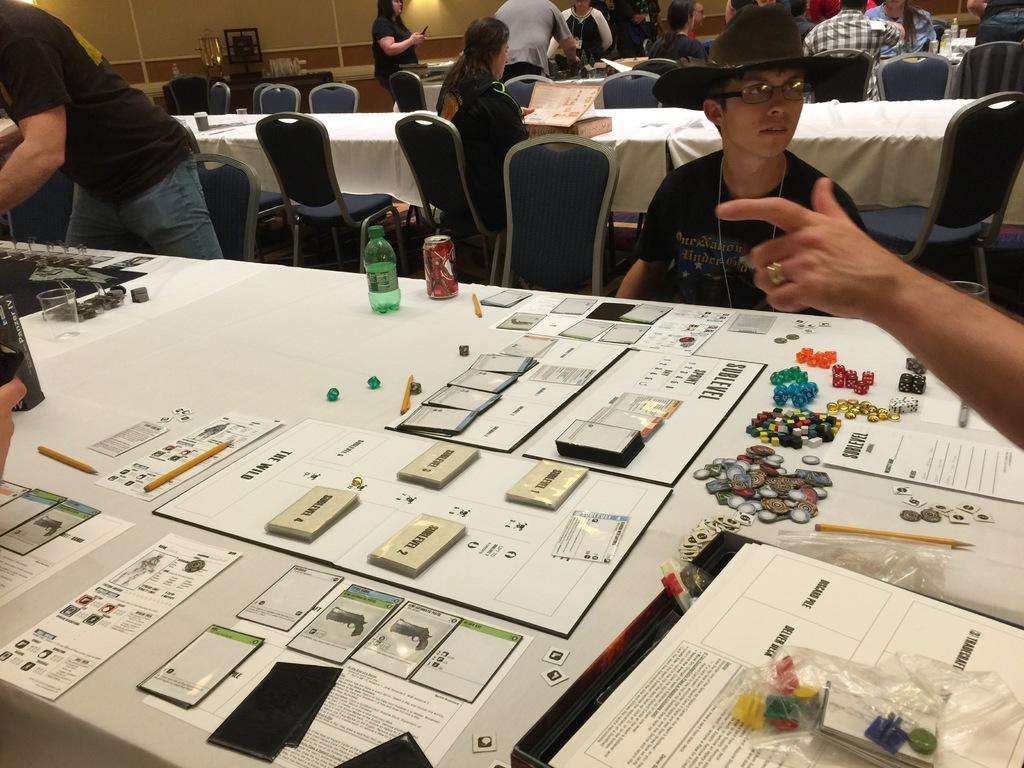What is the main piece of furniture in the image? There is a table in the image. What items can be seen on the table? The table has cards, coins, a bottle, and a tin on it. What are the people in the image doing? Some people are sitting on chairs, and some are standing. How many clover leaves can be seen on the table in the image? There are no clover leaves present in the image. What type of cloud is visible in the image? There is no cloud visible in the image, as it is an indoor scene. 